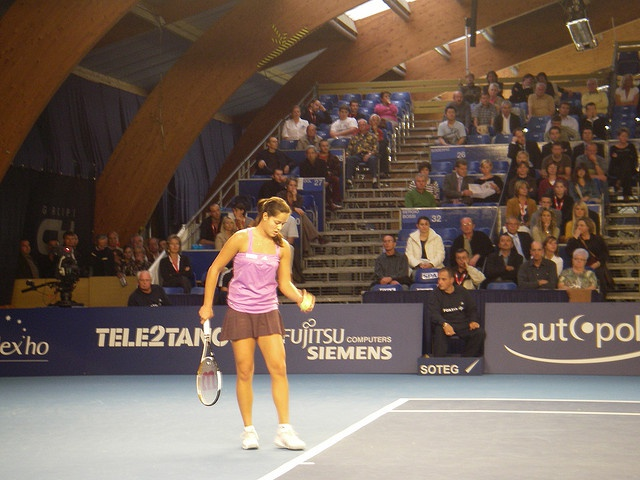Describe the objects in this image and their specific colors. I can see people in black, maroon, and gray tones, people in black, orange, lightgray, brown, and gold tones, chair in black and gray tones, people in black, tan, and gray tones, and tennis racket in black, ivory, darkgray, and tan tones in this image. 